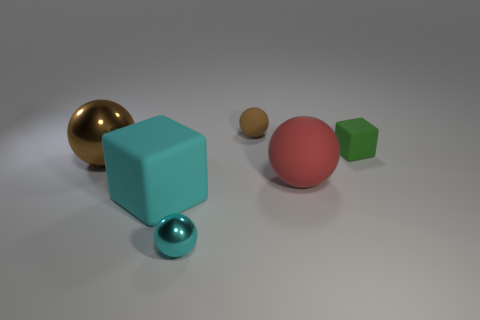There is a ball that is the same color as the large cube; what material is it?
Offer a terse response. Metal. Is there a large blue thing made of the same material as the small cube?
Your response must be concise. No. There is a cyan shiny object; does it have the same shape as the object that is behind the tiny block?
Your answer should be very brief. Yes. There is a green matte object; are there any tiny cyan metallic objects on the left side of it?
Offer a very short reply. Yes. How many green rubber objects are the same shape as the large cyan object?
Keep it short and to the point. 1. Are the large brown ball and the tiny sphere that is behind the big brown shiny sphere made of the same material?
Keep it short and to the point. No. How many metallic things are there?
Offer a very short reply. 2. There is a thing that is in front of the big cyan matte thing; what is its size?
Your answer should be compact. Small. What number of cylinders are the same size as the brown matte sphere?
Provide a succinct answer. 0. There is a small object that is behind the cyan cube and left of the tiny green block; what material is it?
Give a very brief answer. Rubber. 